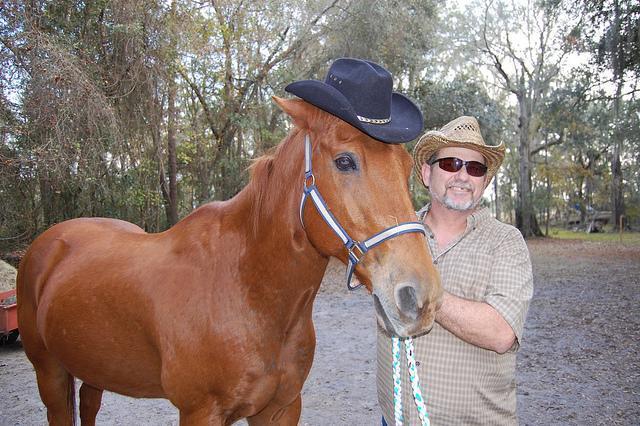How many orange balloons are in the picture?
Give a very brief answer. 0. 